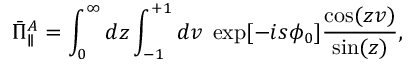<formula> <loc_0><loc_0><loc_500><loc_500>\bar { \Pi } _ { \| } ^ { A } = \int _ { 0 } ^ { \infty } d z \int _ { - 1 } ^ { + 1 } d v \, \exp [ { - i s \phi _ { 0 } } ] \frac { \cos ( z v ) } { \sin ( z ) } ,</formula> 